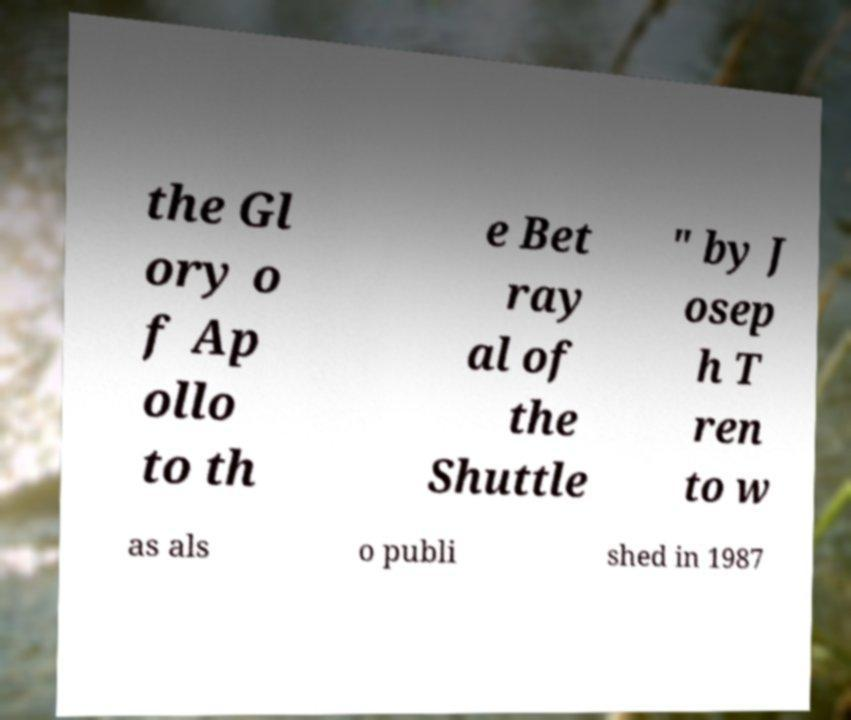What messages or text are displayed in this image? I need them in a readable, typed format. the Gl ory o f Ap ollo to th e Bet ray al of the Shuttle " by J osep h T ren to w as als o publi shed in 1987 